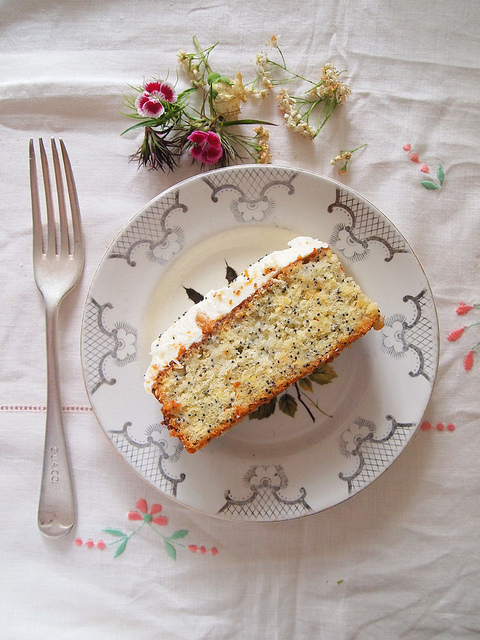Can you describe the cake's texture and appearance? The cake appears to be a slice of a multi-layered creation, exhibiting a spongy and moist texture. The slice is interspersed with what looks like tiny seeds or perhaps small fruit pieces, adding a varied texture. The top of the cake is beautifully adorned with a generous layer of white frosting, adding an appealing finish. 